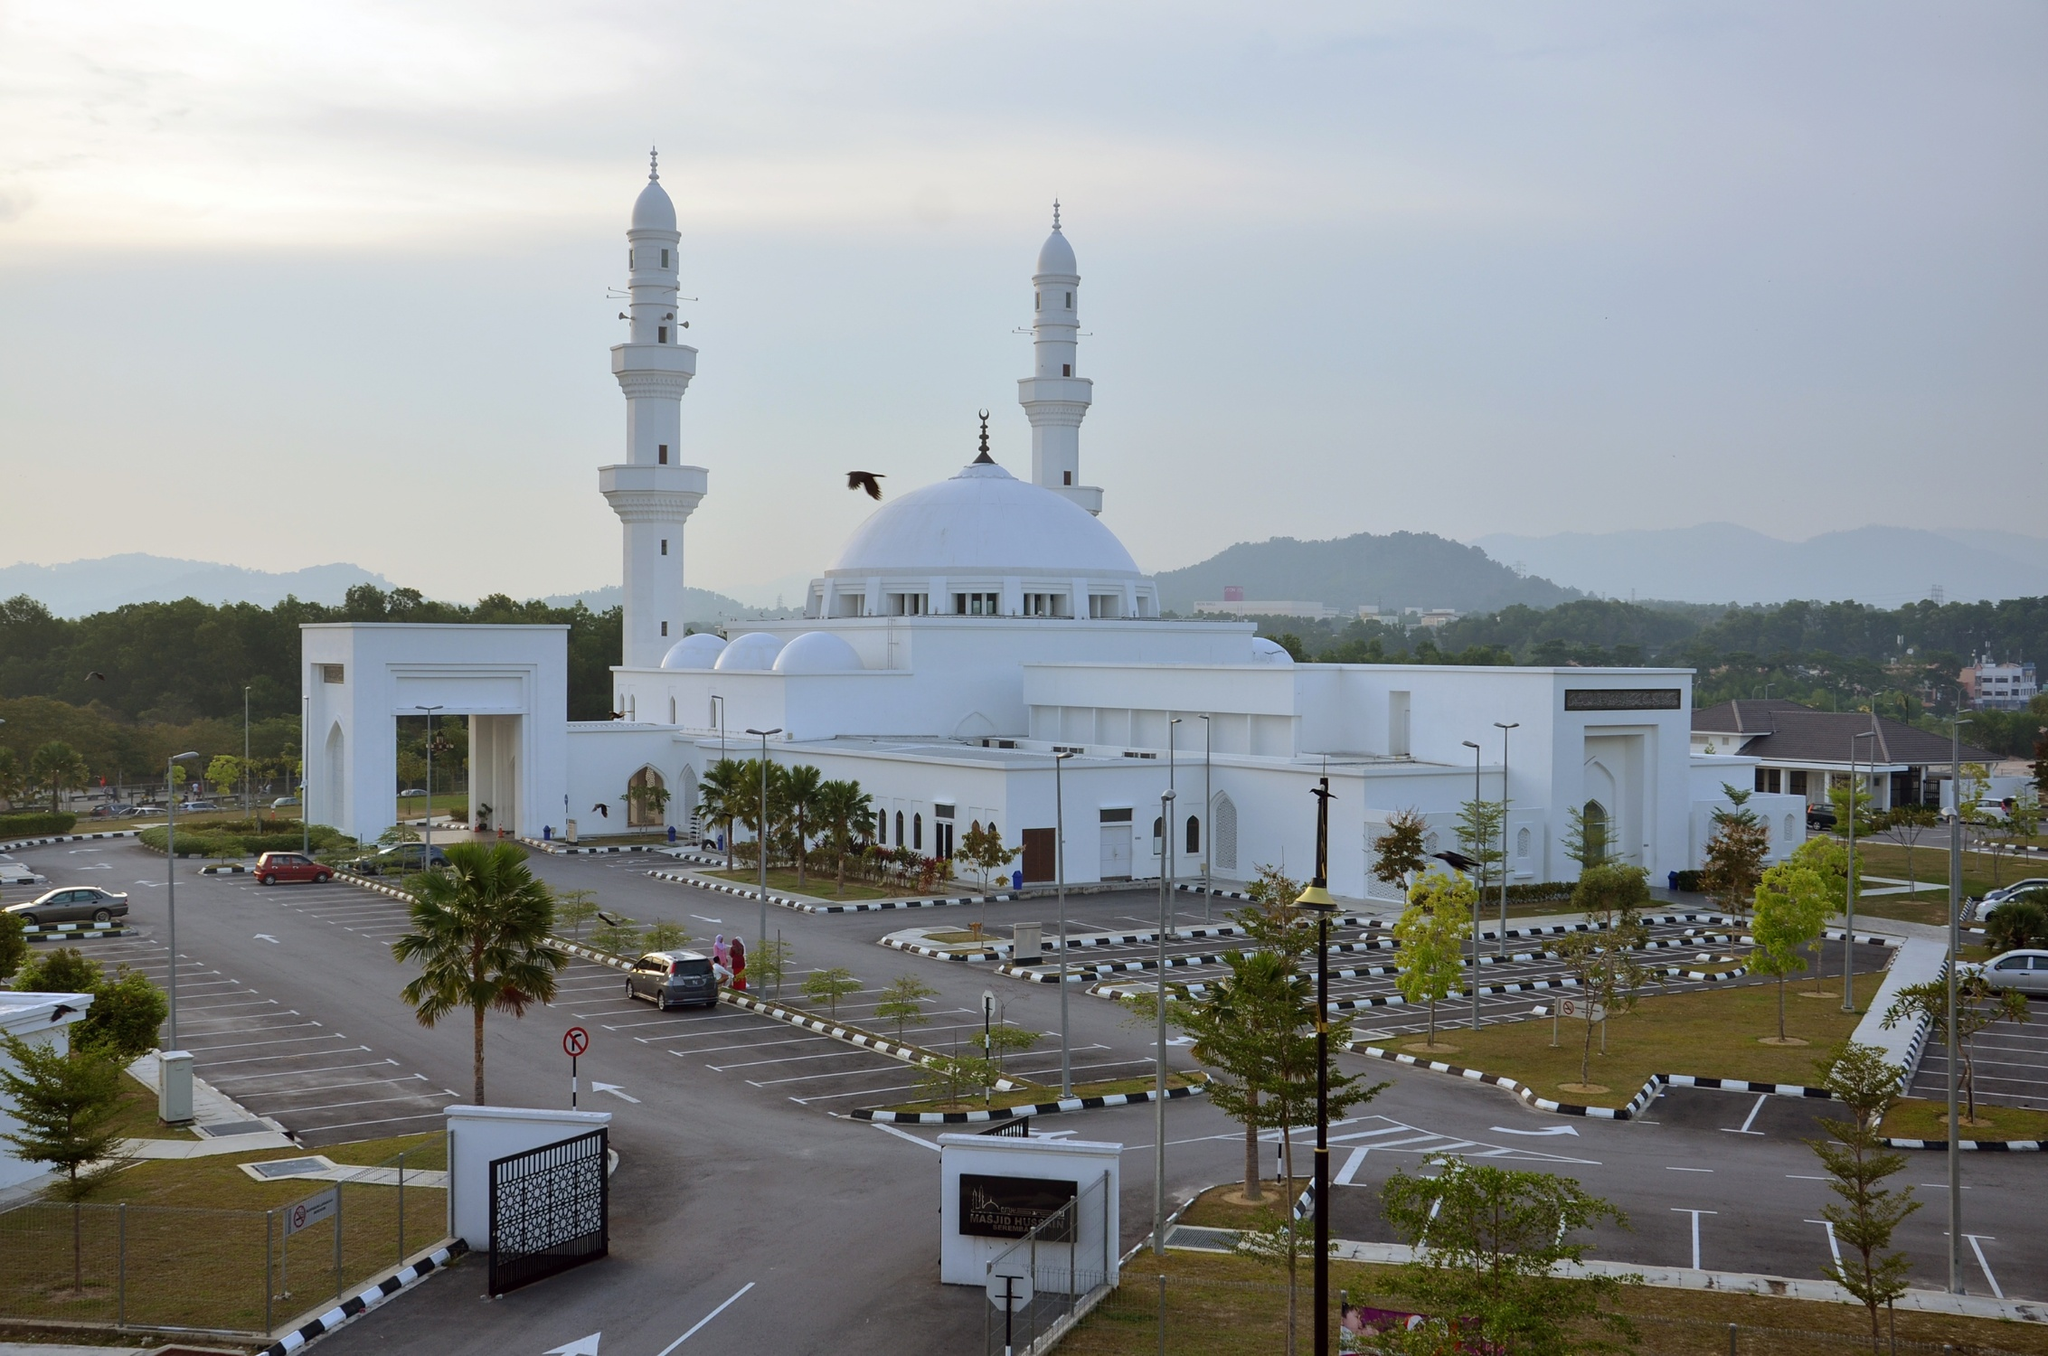What can you tell me about the architectural style of this mosque? The architectural style of the mosque shown in the image is modern with traditional Islamic influences. The large dome is a typical feature of Islamic architecture, symbolizing the heavens and the universe. The minarets, from where the call to prayer is announced, combine both functional and aesthetic elements, crafted to stand out in the skyline. The use of white throughout the building enhances its purity and elegance, which are significant in Islamic religious structures. 